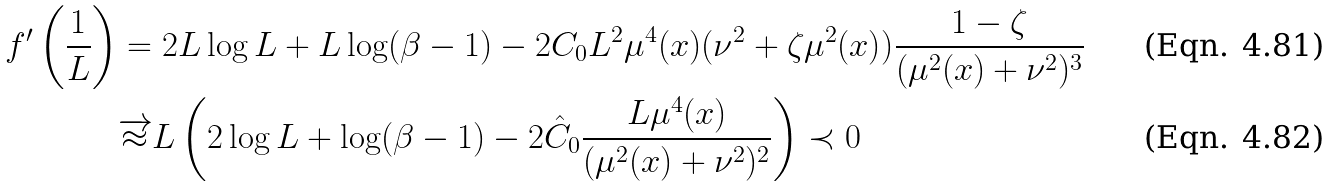<formula> <loc_0><loc_0><loc_500><loc_500>f ^ { \prime } \left ( \frac { 1 } { L } \right ) & = 2 L \log L + L \log ( \beta - 1 ) - 2 C _ { 0 } L ^ { 2 } \mu ^ { 4 } ( { x } ) ( \nu ^ { 2 } + \zeta \mu ^ { 2 } ( { x } ) ) \frac { 1 - \zeta } { ( \mu ^ { 2 } ( { x } ) + \nu ^ { 2 } ) ^ { 3 } } \\ & \overrightarrow { \approx } L \left ( 2 \log L + \log ( \beta - 1 ) - 2 \hat { C } _ { 0 } \frac { L \mu ^ { 4 } ( { x } ) } { ( \mu ^ { 2 } ( { x } ) + \nu ^ { 2 } ) ^ { 2 } } \right ) \prec 0</formula> 